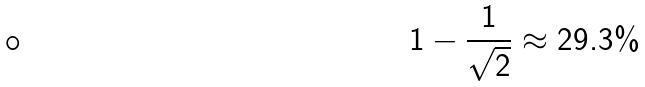Convert formula to latex. <formula><loc_0><loc_0><loc_500><loc_500>1 - \frac { 1 } { \sqrt { 2 } } \approx 2 9 . 3 \%</formula> 